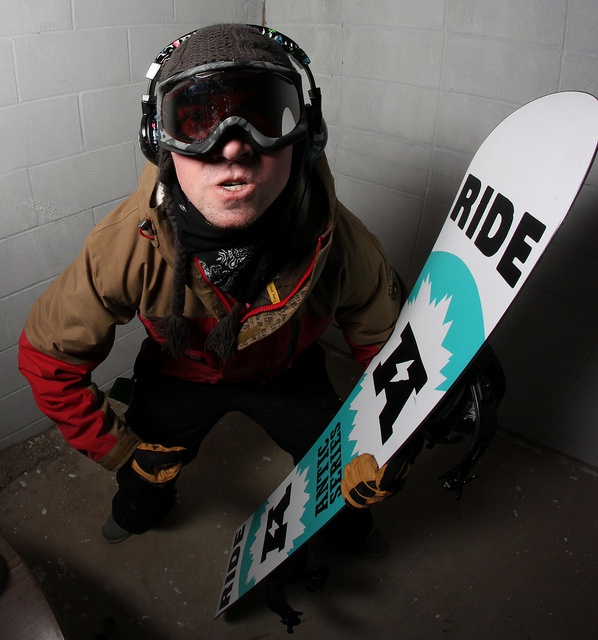Describe the objects in this image and their specific colors. I can see people in lightgray, black, maroon, and gray tones and snowboard in lightgray, black, darkgray, and turquoise tones in this image. 